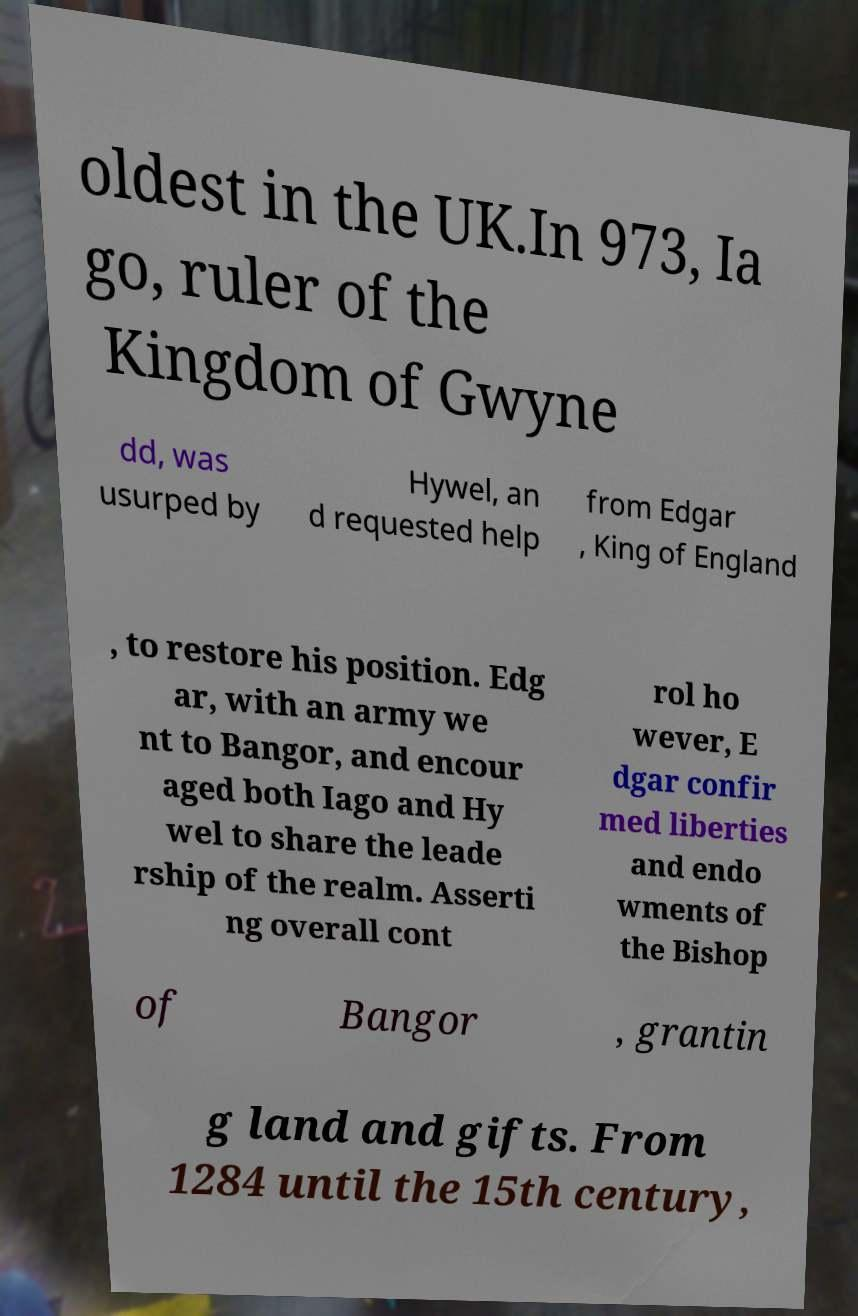I need the written content from this picture converted into text. Can you do that? oldest in the UK.In 973, Ia go, ruler of the Kingdom of Gwyne dd, was usurped by Hywel, an d requested help from Edgar , King of England , to restore his position. Edg ar, with an army we nt to Bangor, and encour aged both Iago and Hy wel to share the leade rship of the realm. Asserti ng overall cont rol ho wever, E dgar confir med liberties and endo wments of the Bishop of Bangor , grantin g land and gifts. From 1284 until the 15th century, 